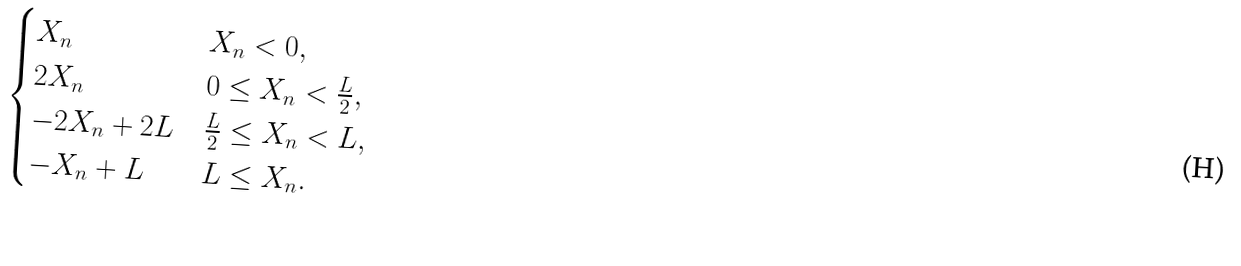Convert formula to latex. <formula><loc_0><loc_0><loc_500><loc_500>\begin{cases} X _ { n } & X _ { n } < 0 , \\ 2 X _ { n } & 0 \leq X _ { n } < \frac { L } { 2 } , \\ - 2 X _ { n } + 2 L & \frac { L } { 2 } \leq X _ { n } < L , \\ - X _ { n } + L & L \leq X _ { n } . \end{cases}</formula> 